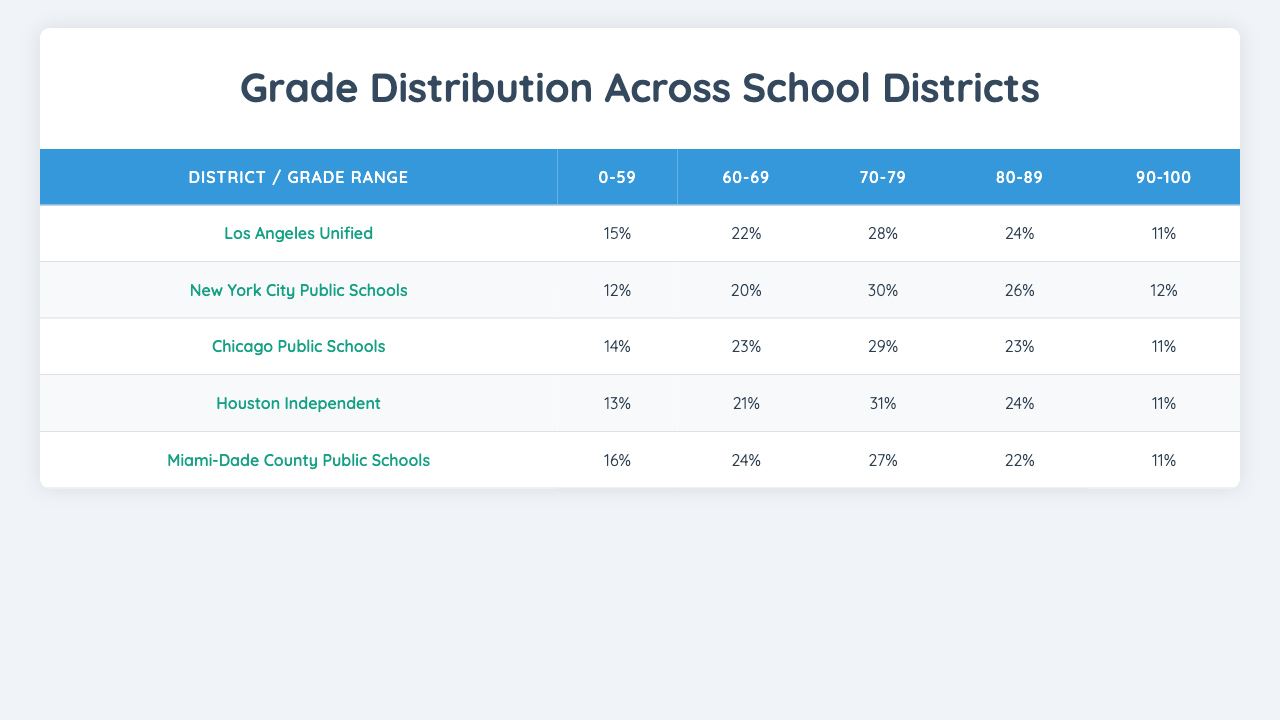What percentage of students in Los Angeles Unified scored in the 80-89 range? Referring to the table, the percentage for the 80-89 range under Los Angeles Unified is 24%.
Answer: 24% Which district had the highest percentage of students scoring between 70-79? Looking at the 70-79 range, Chicago Public Schools has the highest percentage at 29%.
Answer: Chicago Public Schools What is the total percentage of students from Miami-Dade County Public Schools who scored below 70? To find this, we add the percentages for the ranges 0-59 and 60-69: 16% + 24% = 40%.
Answer: 40% Did any district have exactly 11% of students scoring in the 90-100 range? Yes, both Los Angeles Unified and Miami-Dade County Public Schools have 11% of students in the 90-100 range.
Answer: Yes Which district had the lowest percentage of students scoring between 60-69? By checking the table, the district with the lowest percentage in the 60-69 range is New York City Public Schools, with 20%.
Answer: New York City Public Schools If you combine the scores for all districts in the 90-100 range, what is the total percentage? The percentages for the 90-100 range are 11% (Los Angeles), 12% (New York), 11% (Chicago), 11% (Houston), and 11% (Miami-Dade). Adding these gives: 11 + 12 + 11 + 11 + 11 = 56%.
Answer: 56% What is the average percentage of students who scored in the 70-79 range across all districts? The values for the 70-79 range are 28% (Los Angeles), 30% (New York), 29% (Chicago), 31% (Houston), and 27% (Miami-Dade). Adding these gives 28 + 30 + 29 + 31 + 27 = 145, and dividing by 5 gives an average of 29%.
Answer: 29% Which test type has the highest percentage of students scoring in the 0-59 range across all districts? This requires gathering the 0-59 percentages for each district across various test types. Since the specific score distribution is not tied to a particular test type in the table, this question is not directly answerable.
Answer: Cannot determine Is there any district that scored 22% in the 80-89 range? Yes, Miami-Dade County Public Schools has a score of 22% in the 80-89 range.
Answer: Yes What is the difference in percentage between the highest and lowest scoring district in the 60-69 range? The highest percentage in this range is from Houston Independent (21%) and the lowest is New York City Public Schools (20%). The difference is 21% - 20% = 1%.
Answer: 1% 